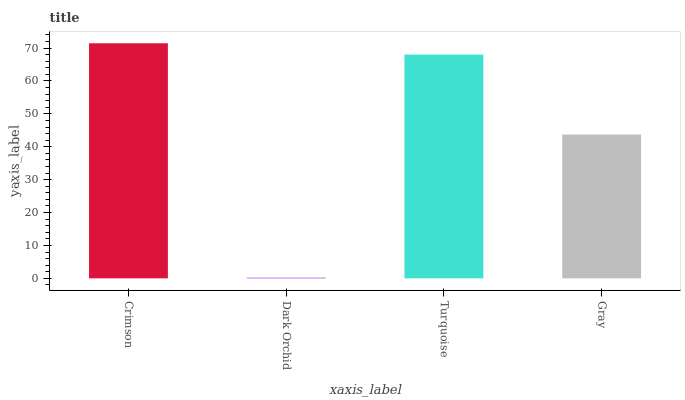Is Dark Orchid the minimum?
Answer yes or no. Yes. Is Crimson the maximum?
Answer yes or no. Yes. Is Turquoise the minimum?
Answer yes or no. No. Is Turquoise the maximum?
Answer yes or no. No. Is Turquoise greater than Dark Orchid?
Answer yes or no. Yes. Is Dark Orchid less than Turquoise?
Answer yes or no. Yes. Is Dark Orchid greater than Turquoise?
Answer yes or no. No. Is Turquoise less than Dark Orchid?
Answer yes or no. No. Is Turquoise the high median?
Answer yes or no. Yes. Is Gray the low median?
Answer yes or no. Yes. Is Dark Orchid the high median?
Answer yes or no. No. Is Dark Orchid the low median?
Answer yes or no. No. 